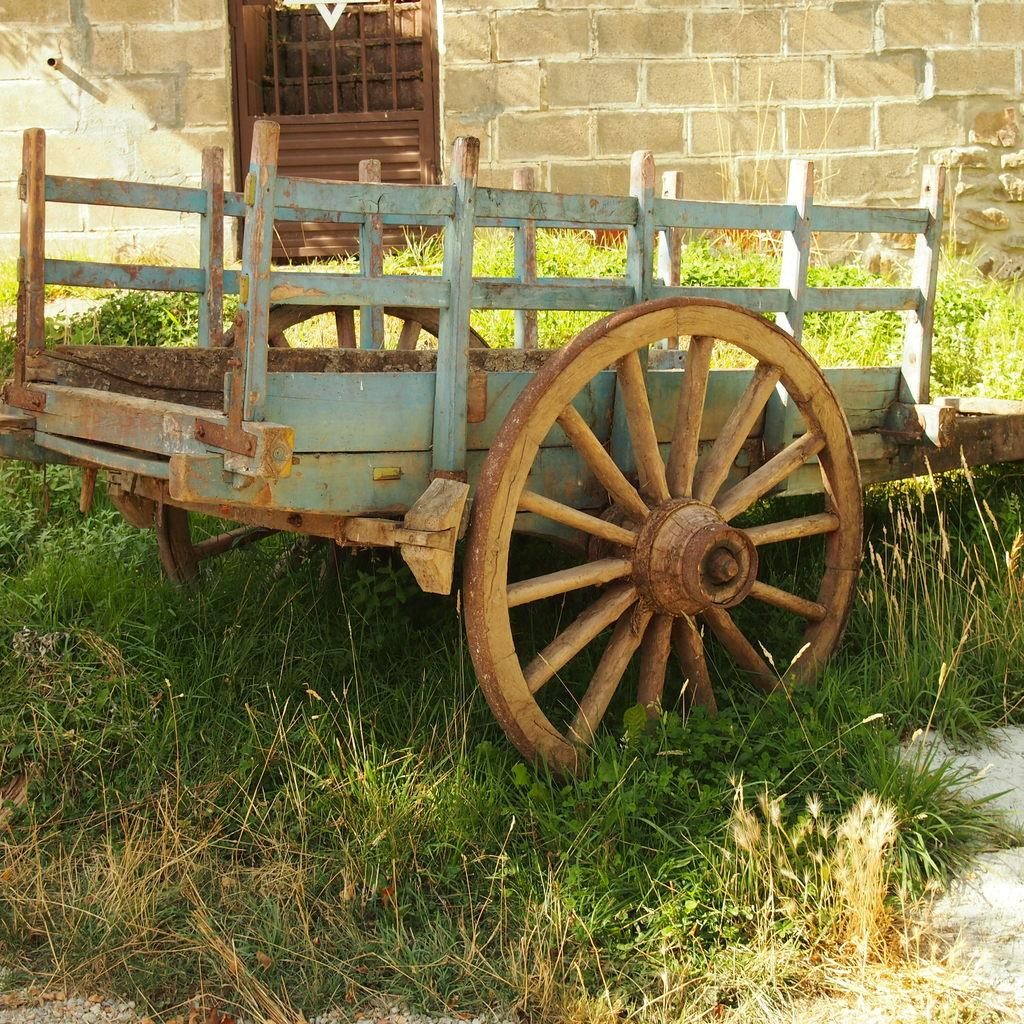What object is on the ground in the image? There is a cart on the ground in the image. What type of living organisms can be seen in the image? There are plants in the image. What feature of a building is visible in the image? There is a door in the image. What can be seen in the background of the image? There is a wall visible in the background of the image. How many boys are holding the chain in the image? There are no boys or chains present in the image. 